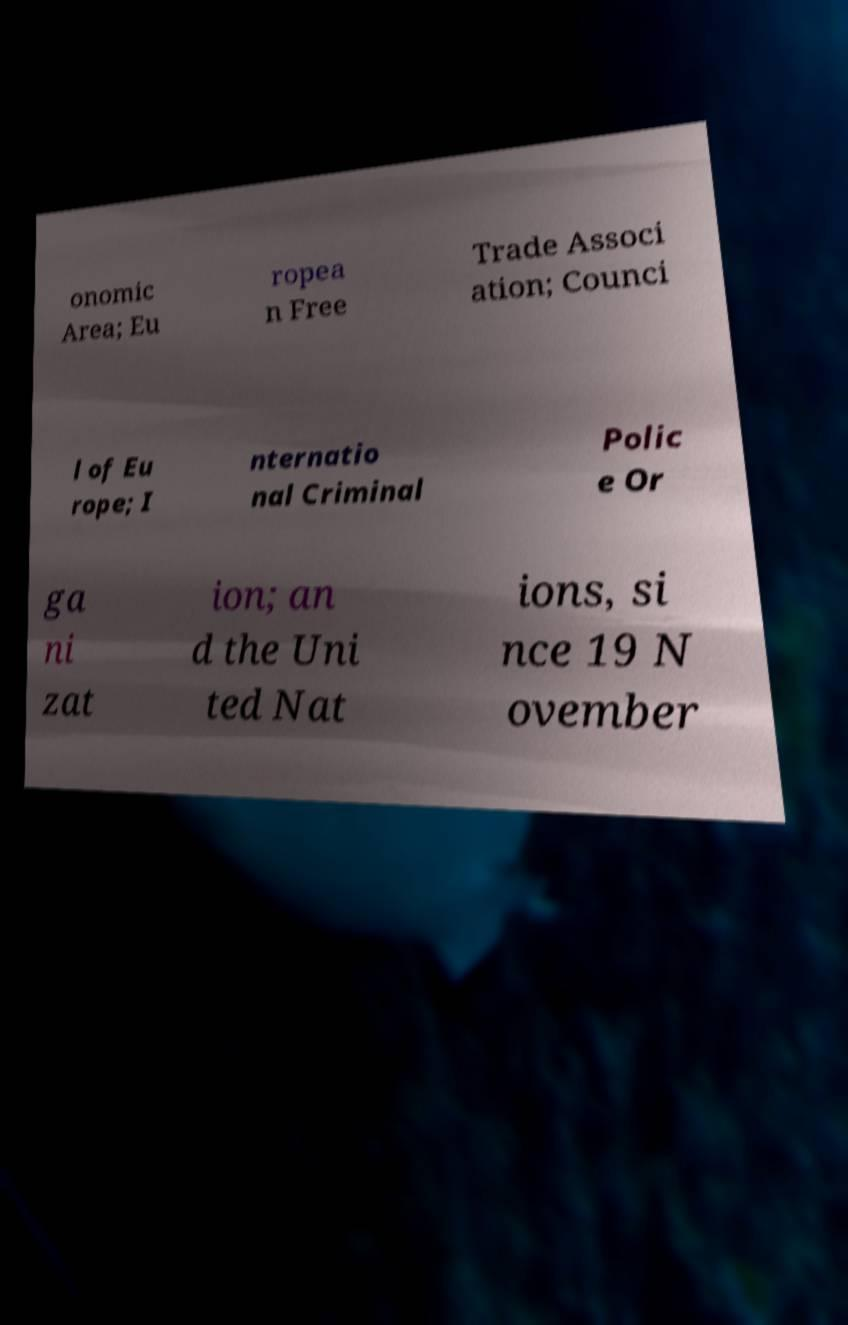Please read and relay the text visible in this image. What does it say? onomic Area; Eu ropea n Free Trade Associ ation; Counci l of Eu rope; I nternatio nal Criminal Polic e Or ga ni zat ion; an d the Uni ted Nat ions, si nce 19 N ovember 